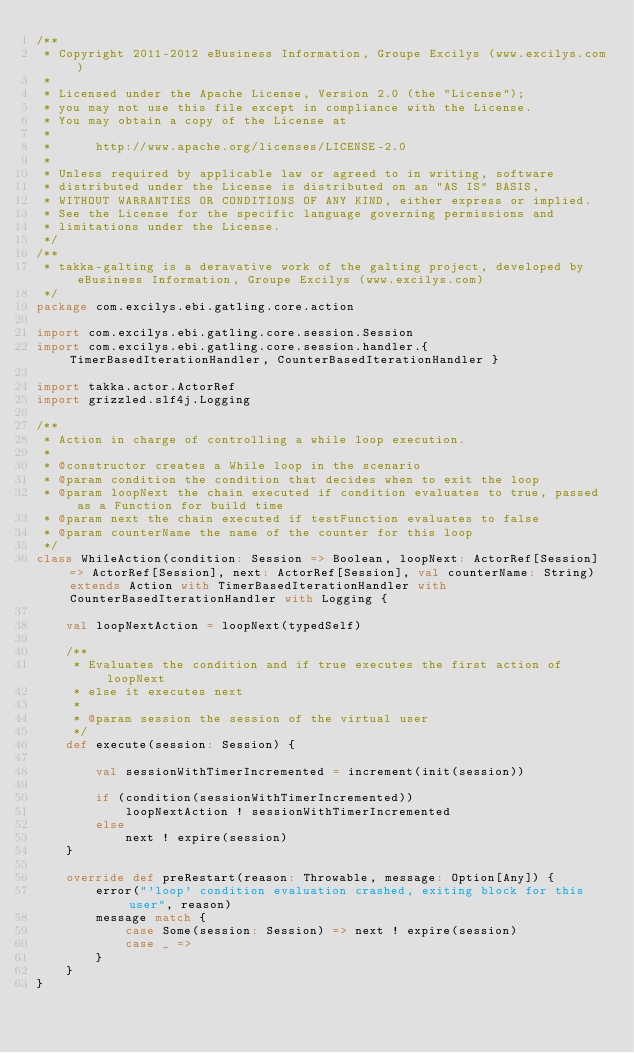Convert code to text. <code><loc_0><loc_0><loc_500><loc_500><_Scala_>/**
 * Copyright 2011-2012 eBusiness Information, Groupe Excilys (www.excilys.com)
 *
 * Licensed under the Apache License, Version 2.0 (the "License");
 * you may not use this file except in compliance with the License.
 * You may obtain a copy of the License at
 *
 * 		http://www.apache.org/licenses/LICENSE-2.0
 *
 * Unless required by applicable law or agreed to in writing, software
 * distributed under the License is distributed on an "AS IS" BASIS,
 * WITHOUT WARRANTIES OR CONDITIONS OF ANY KIND, either express or implied.
 * See the License for the specific language governing permissions and
 * limitations under the License.
 */
/**
 * takka-galting is a deravative work of the galting project, developed by eBusiness Information, Groupe Excilys (www.excilys.com)
 */
package com.excilys.ebi.gatling.core.action

import com.excilys.ebi.gatling.core.session.Session
import com.excilys.ebi.gatling.core.session.handler.{ TimerBasedIterationHandler, CounterBasedIterationHandler }

import takka.actor.ActorRef
import grizzled.slf4j.Logging

/**
 * Action in charge of controlling a while loop execution.
 *
 * @constructor creates a While loop in the scenario
 * @param condition the condition that decides when to exit the loop
 * @param loopNext the chain executed if condition evaluates to true, passed as a Function for build time
 * @param next the chain executed if testFunction evaluates to false
 * @param counterName the name of the counter for this loop
 */
class WhileAction(condition: Session => Boolean, loopNext: ActorRef[Session] => ActorRef[Session], next: ActorRef[Session], val counterName: String) extends Action with TimerBasedIterationHandler with CounterBasedIterationHandler with Logging {

	val loopNextAction = loopNext(typedSelf)

	/**
	 * Evaluates the condition and if true executes the first action of loopNext
	 * else it executes next
	 *
	 * @param session the session of the virtual user
	 */
	def execute(session: Session) {

		val sessionWithTimerIncremented = increment(init(session))

		if (condition(sessionWithTimerIncremented))
			loopNextAction ! sessionWithTimerIncremented
		else
			next ! expire(session)
	}

	override def preRestart(reason: Throwable, message: Option[Any]) {
		error("'loop' condition evaluation crashed, exiting block for this user", reason)
		message match {
			case Some(session: Session) => next ! expire(session)
			case _ =>
		}
	}
}</code> 